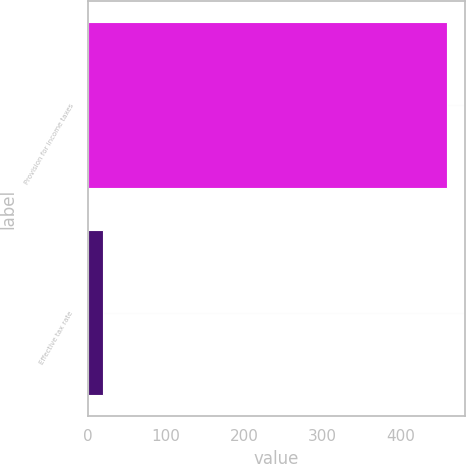Convert chart. <chart><loc_0><loc_0><loc_500><loc_500><bar_chart><fcel>Provision for income taxes<fcel>Effective tax rate<nl><fcel>459<fcel>19<nl></chart> 